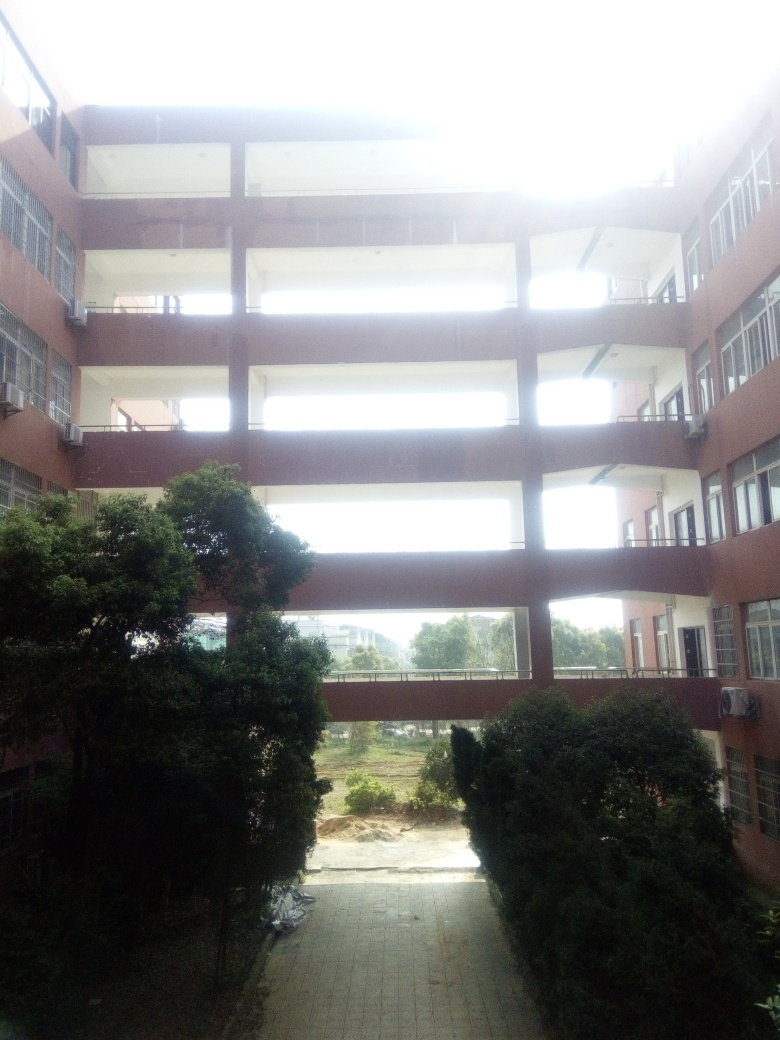Can you describe the architectural design of the building in the image? The building presents a modern architectural design with symmetrical features. It consists of multiple levels with open-air walkways connecting different sections. The structure uses horizontal lines prominently, which contribute to a sense of stability and horizontal flow. The use of large, open spaces is reminiscent of brutalist architecture, which often includes raw concrete structures, though the material here cannot be confirmed from the image. 